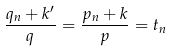Convert formula to latex. <formula><loc_0><loc_0><loc_500><loc_500>\frac { q _ { n } + k ^ { \prime } } { q } = \frac { p _ { n } + k } { p } = t _ { n }</formula> 